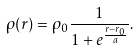<formula> <loc_0><loc_0><loc_500><loc_500>\rho ( r ) = \rho _ { 0 } \frac { 1 } { 1 + e ^ { \frac { r - r _ { 0 } } { a } } } .</formula> 